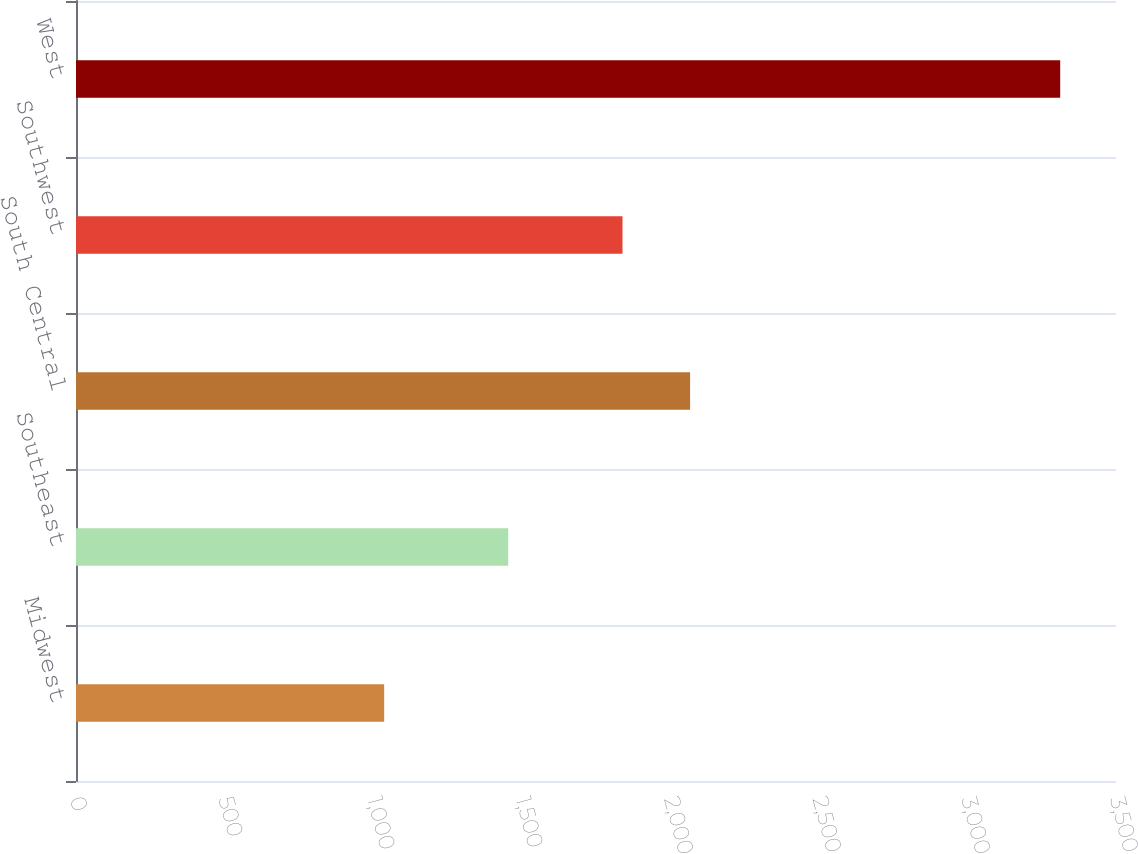Convert chart to OTSL. <chart><loc_0><loc_0><loc_500><loc_500><bar_chart><fcel>Midwest<fcel>Southeast<fcel>South Central<fcel>Southwest<fcel>West<nl><fcel>1037.1<fcel>1454.6<fcel>2066.71<fcel>1839.2<fcel>3312.2<nl></chart> 